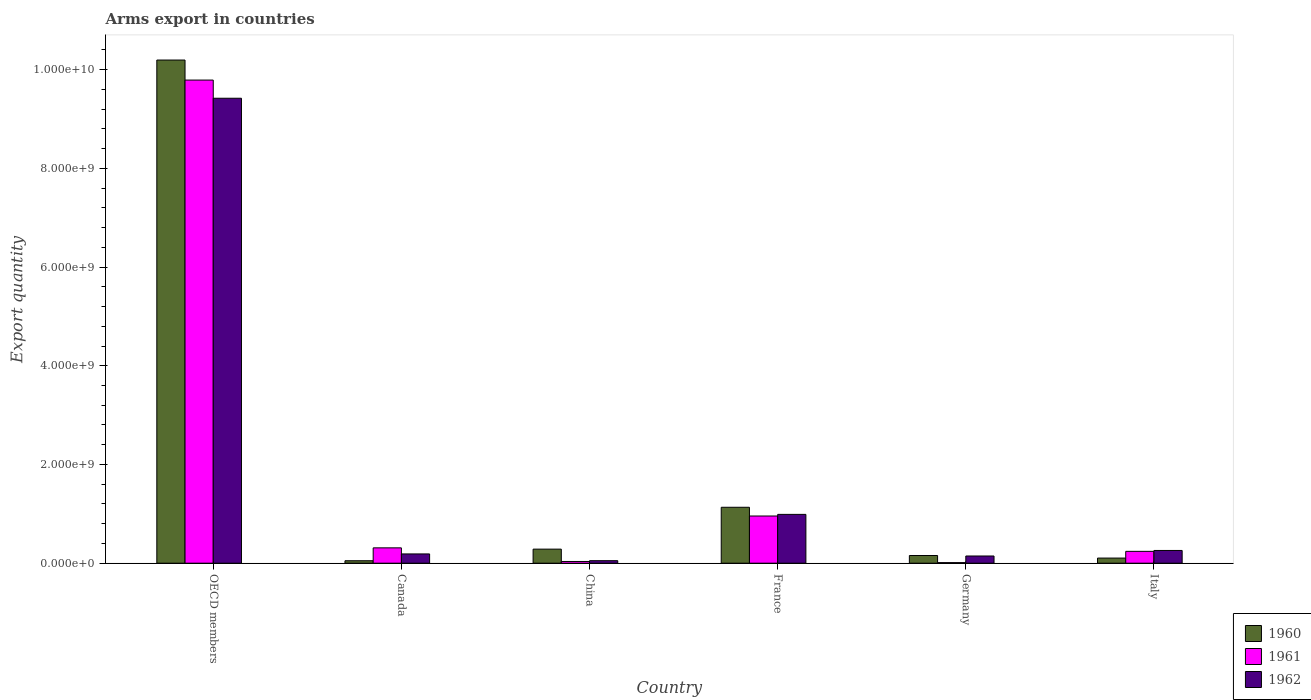How many groups of bars are there?
Your response must be concise. 6. Are the number of bars per tick equal to the number of legend labels?
Make the answer very short. Yes. How many bars are there on the 6th tick from the left?
Ensure brevity in your answer.  3. In how many cases, is the number of bars for a given country not equal to the number of legend labels?
Your answer should be compact. 0. What is the total arms export in 1961 in France?
Give a very brief answer. 9.56e+08. Across all countries, what is the maximum total arms export in 1960?
Your response must be concise. 1.02e+1. Across all countries, what is the minimum total arms export in 1962?
Provide a succinct answer. 5.10e+07. In which country was the total arms export in 1962 maximum?
Provide a succinct answer. OECD members. In which country was the total arms export in 1960 minimum?
Your response must be concise. Canada. What is the total total arms export in 1960 in the graph?
Your answer should be compact. 1.19e+1. What is the difference between the total arms export in 1961 in China and that in OECD members?
Offer a very short reply. -9.75e+09. What is the difference between the total arms export in 1960 in Canada and the total arms export in 1962 in Germany?
Ensure brevity in your answer.  -9.60e+07. What is the average total arms export in 1961 per country?
Keep it short and to the point. 1.89e+09. What is the difference between the total arms export of/in 1962 and total arms export of/in 1961 in OECD members?
Keep it short and to the point. -3.68e+08. In how many countries, is the total arms export in 1961 greater than 2000000000?
Ensure brevity in your answer.  1. What is the ratio of the total arms export in 1960 in Canada to that in China?
Your answer should be very brief. 0.18. Is the total arms export in 1962 in Canada less than that in China?
Keep it short and to the point. No. Is the difference between the total arms export in 1962 in Canada and China greater than the difference between the total arms export in 1961 in Canada and China?
Keep it short and to the point. No. What is the difference between the highest and the second highest total arms export in 1960?
Ensure brevity in your answer.  9.91e+09. What is the difference between the highest and the lowest total arms export in 1962?
Ensure brevity in your answer.  9.37e+09. Is the sum of the total arms export in 1961 in Canada and Italy greater than the maximum total arms export in 1962 across all countries?
Offer a very short reply. No. What does the 3rd bar from the left in Germany represents?
Give a very brief answer. 1962. Is it the case that in every country, the sum of the total arms export in 1960 and total arms export in 1962 is greater than the total arms export in 1961?
Offer a terse response. No. How many countries are there in the graph?
Make the answer very short. 6. Does the graph contain any zero values?
Give a very brief answer. No. Does the graph contain grids?
Your answer should be very brief. No. How many legend labels are there?
Keep it short and to the point. 3. What is the title of the graph?
Offer a very short reply. Arms export in countries. Does "1976" appear as one of the legend labels in the graph?
Your answer should be compact. No. What is the label or title of the X-axis?
Make the answer very short. Country. What is the label or title of the Y-axis?
Ensure brevity in your answer.  Export quantity. What is the Export quantity of 1960 in OECD members?
Your response must be concise. 1.02e+1. What is the Export quantity of 1961 in OECD members?
Your answer should be compact. 9.79e+09. What is the Export quantity in 1962 in OECD members?
Offer a very short reply. 9.42e+09. What is the Export quantity in 1961 in Canada?
Your answer should be very brief. 3.11e+08. What is the Export quantity of 1962 in Canada?
Provide a succinct answer. 1.88e+08. What is the Export quantity in 1960 in China?
Your answer should be very brief. 2.85e+08. What is the Export quantity of 1961 in China?
Offer a very short reply. 3.50e+07. What is the Export quantity in 1962 in China?
Your answer should be very brief. 5.10e+07. What is the Export quantity in 1960 in France?
Provide a succinct answer. 1.13e+09. What is the Export quantity in 1961 in France?
Ensure brevity in your answer.  9.56e+08. What is the Export quantity of 1962 in France?
Provide a succinct answer. 9.89e+08. What is the Export quantity of 1960 in Germany?
Keep it short and to the point. 1.56e+08. What is the Export quantity of 1962 in Germany?
Offer a terse response. 1.46e+08. What is the Export quantity of 1960 in Italy?
Offer a terse response. 1.04e+08. What is the Export quantity of 1961 in Italy?
Offer a terse response. 2.40e+08. What is the Export quantity of 1962 in Italy?
Your response must be concise. 2.58e+08. Across all countries, what is the maximum Export quantity in 1960?
Ensure brevity in your answer.  1.02e+1. Across all countries, what is the maximum Export quantity in 1961?
Your answer should be compact. 9.79e+09. Across all countries, what is the maximum Export quantity of 1962?
Make the answer very short. 9.42e+09. Across all countries, what is the minimum Export quantity of 1960?
Offer a terse response. 5.00e+07. Across all countries, what is the minimum Export quantity of 1962?
Offer a very short reply. 5.10e+07. What is the total Export quantity in 1960 in the graph?
Give a very brief answer. 1.19e+1. What is the total Export quantity in 1961 in the graph?
Offer a very short reply. 1.13e+1. What is the total Export quantity of 1962 in the graph?
Your response must be concise. 1.11e+1. What is the difference between the Export quantity of 1960 in OECD members and that in Canada?
Give a very brief answer. 1.01e+1. What is the difference between the Export quantity in 1961 in OECD members and that in Canada?
Make the answer very short. 9.48e+09. What is the difference between the Export quantity in 1962 in OECD members and that in Canada?
Offer a terse response. 9.23e+09. What is the difference between the Export quantity of 1960 in OECD members and that in China?
Provide a short and direct response. 9.91e+09. What is the difference between the Export quantity in 1961 in OECD members and that in China?
Provide a short and direct response. 9.75e+09. What is the difference between the Export quantity in 1962 in OECD members and that in China?
Offer a terse response. 9.37e+09. What is the difference between the Export quantity in 1960 in OECD members and that in France?
Offer a very short reply. 9.06e+09. What is the difference between the Export quantity of 1961 in OECD members and that in France?
Offer a very short reply. 8.83e+09. What is the difference between the Export quantity of 1962 in OECD members and that in France?
Make the answer very short. 8.43e+09. What is the difference between the Export quantity of 1960 in OECD members and that in Germany?
Provide a short and direct response. 1.00e+1. What is the difference between the Export quantity in 1961 in OECD members and that in Germany?
Make the answer very short. 9.78e+09. What is the difference between the Export quantity in 1962 in OECD members and that in Germany?
Offer a terse response. 9.27e+09. What is the difference between the Export quantity of 1960 in OECD members and that in Italy?
Make the answer very short. 1.01e+1. What is the difference between the Export quantity of 1961 in OECD members and that in Italy?
Your response must be concise. 9.55e+09. What is the difference between the Export quantity of 1962 in OECD members and that in Italy?
Give a very brief answer. 9.16e+09. What is the difference between the Export quantity of 1960 in Canada and that in China?
Your response must be concise. -2.35e+08. What is the difference between the Export quantity in 1961 in Canada and that in China?
Keep it short and to the point. 2.76e+08. What is the difference between the Export quantity of 1962 in Canada and that in China?
Keep it short and to the point. 1.37e+08. What is the difference between the Export quantity in 1960 in Canada and that in France?
Make the answer very short. -1.08e+09. What is the difference between the Export quantity in 1961 in Canada and that in France?
Your answer should be compact. -6.45e+08. What is the difference between the Export quantity in 1962 in Canada and that in France?
Keep it short and to the point. -8.01e+08. What is the difference between the Export quantity of 1960 in Canada and that in Germany?
Your response must be concise. -1.06e+08. What is the difference between the Export quantity in 1961 in Canada and that in Germany?
Your answer should be very brief. 2.99e+08. What is the difference between the Export quantity of 1962 in Canada and that in Germany?
Your answer should be very brief. 4.20e+07. What is the difference between the Export quantity in 1960 in Canada and that in Italy?
Your answer should be compact. -5.40e+07. What is the difference between the Export quantity of 1961 in Canada and that in Italy?
Provide a succinct answer. 7.10e+07. What is the difference between the Export quantity in 1962 in Canada and that in Italy?
Your answer should be very brief. -7.00e+07. What is the difference between the Export quantity in 1960 in China and that in France?
Make the answer very short. -8.48e+08. What is the difference between the Export quantity in 1961 in China and that in France?
Provide a succinct answer. -9.21e+08. What is the difference between the Export quantity of 1962 in China and that in France?
Offer a terse response. -9.38e+08. What is the difference between the Export quantity of 1960 in China and that in Germany?
Make the answer very short. 1.29e+08. What is the difference between the Export quantity in 1961 in China and that in Germany?
Your response must be concise. 2.30e+07. What is the difference between the Export quantity in 1962 in China and that in Germany?
Your response must be concise. -9.50e+07. What is the difference between the Export quantity of 1960 in China and that in Italy?
Provide a succinct answer. 1.81e+08. What is the difference between the Export quantity of 1961 in China and that in Italy?
Offer a very short reply. -2.05e+08. What is the difference between the Export quantity in 1962 in China and that in Italy?
Keep it short and to the point. -2.07e+08. What is the difference between the Export quantity of 1960 in France and that in Germany?
Offer a terse response. 9.77e+08. What is the difference between the Export quantity in 1961 in France and that in Germany?
Offer a very short reply. 9.44e+08. What is the difference between the Export quantity of 1962 in France and that in Germany?
Provide a short and direct response. 8.43e+08. What is the difference between the Export quantity in 1960 in France and that in Italy?
Provide a succinct answer. 1.03e+09. What is the difference between the Export quantity in 1961 in France and that in Italy?
Provide a succinct answer. 7.16e+08. What is the difference between the Export quantity in 1962 in France and that in Italy?
Keep it short and to the point. 7.31e+08. What is the difference between the Export quantity of 1960 in Germany and that in Italy?
Give a very brief answer. 5.20e+07. What is the difference between the Export quantity in 1961 in Germany and that in Italy?
Provide a succinct answer. -2.28e+08. What is the difference between the Export quantity in 1962 in Germany and that in Italy?
Give a very brief answer. -1.12e+08. What is the difference between the Export quantity in 1960 in OECD members and the Export quantity in 1961 in Canada?
Provide a succinct answer. 9.88e+09. What is the difference between the Export quantity in 1960 in OECD members and the Export quantity in 1962 in Canada?
Provide a short and direct response. 1.00e+1. What is the difference between the Export quantity of 1961 in OECD members and the Export quantity of 1962 in Canada?
Your answer should be very brief. 9.60e+09. What is the difference between the Export quantity in 1960 in OECD members and the Export quantity in 1961 in China?
Provide a succinct answer. 1.02e+1. What is the difference between the Export quantity of 1960 in OECD members and the Export quantity of 1962 in China?
Offer a terse response. 1.01e+1. What is the difference between the Export quantity in 1961 in OECD members and the Export quantity in 1962 in China?
Make the answer very short. 9.74e+09. What is the difference between the Export quantity of 1960 in OECD members and the Export quantity of 1961 in France?
Make the answer very short. 9.24e+09. What is the difference between the Export quantity in 1960 in OECD members and the Export quantity in 1962 in France?
Your answer should be very brief. 9.20e+09. What is the difference between the Export quantity in 1961 in OECD members and the Export quantity in 1962 in France?
Your response must be concise. 8.80e+09. What is the difference between the Export quantity of 1960 in OECD members and the Export quantity of 1961 in Germany?
Your answer should be very brief. 1.02e+1. What is the difference between the Export quantity of 1960 in OECD members and the Export quantity of 1962 in Germany?
Your answer should be compact. 1.00e+1. What is the difference between the Export quantity of 1961 in OECD members and the Export quantity of 1962 in Germany?
Your answer should be compact. 9.64e+09. What is the difference between the Export quantity of 1960 in OECD members and the Export quantity of 1961 in Italy?
Provide a short and direct response. 9.95e+09. What is the difference between the Export quantity of 1960 in OECD members and the Export quantity of 1962 in Italy?
Offer a terse response. 9.94e+09. What is the difference between the Export quantity of 1961 in OECD members and the Export quantity of 1962 in Italy?
Provide a short and direct response. 9.53e+09. What is the difference between the Export quantity in 1960 in Canada and the Export quantity in 1961 in China?
Ensure brevity in your answer.  1.50e+07. What is the difference between the Export quantity in 1960 in Canada and the Export quantity in 1962 in China?
Your response must be concise. -1.00e+06. What is the difference between the Export quantity in 1961 in Canada and the Export quantity in 1962 in China?
Keep it short and to the point. 2.60e+08. What is the difference between the Export quantity of 1960 in Canada and the Export quantity of 1961 in France?
Your response must be concise. -9.06e+08. What is the difference between the Export quantity in 1960 in Canada and the Export quantity in 1962 in France?
Offer a very short reply. -9.39e+08. What is the difference between the Export quantity of 1961 in Canada and the Export quantity of 1962 in France?
Provide a short and direct response. -6.78e+08. What is the difference between the Export quantity in 1960 in Canada and the Export quantity in 1961 in Germany?
Give a very brief answer. 3.80e+07. What is the difference between the Export quantity of 1960 in Canada and the Export quantity of 1962 in Germany?
Keep it short and to the point. -9.60e+07. What is the difference between the Export quantity of 1961 in Canada and the Export quantity of 1962 in Germany?
Offer a terse response. 1.65e+08. What is the difference between the Export quantity in 1960 in Canada and the Export quantity in 1961 in Italy?
Give a very brief answer. -1.90e+08. What is the difference between the Export quantity of 1960 in Canada and the Export quantity of 1962 in Italy?
Provide a short and direct response. -2.08e+08. What is the difference between the Export quantity of 1961 in Canada and the Export quantity of 1962 in Italy?
Ensure brevity in your answer.  5.30e+07. What is the difference between the Export quantity of 1960 in China and the Export quantity of 1961 in France?
Offer a very short reply. -6.71e+08. What is the difference between the Export quantity in 1960 in China and the Export quantity in 1962 in France?
Your answer should be compact. -7.04e+08. What is the difference between the Export quantity of 1961 in China and the Export quantity of 1962 in France?
Offer a very short reply. -9.54e+08. What is the difference between the Export quantity of 1960 in China and the Export quantity of 1961 in Germany?
Provide a short and direct response. 2.73e+08. What is the difference between the Export quantity of 1960 in China and the Export quantity of 1962 in Germany?
Your response must be concise. 1.39e+08. What is the difference between the Export quantity in 1961 in China and the Export quantity in 1962 in Germany?
Your answer should be compact. -1.11e+08. What is the difference between the Export quantity in 1960 in China and the Export quantity in 1961 in Italy?
Make the answer very short. 4.50e+07. What is the difference between the Export quantity in 1960 in China and the Export quantity in 1962 in Italy?
Make the answer very short. 2.70e+07. What is the difference between the Export quantity in 1961 in China and the Export quantity in 1962 in Italy?
Offer a terse response. -2.23e+08. What is the difference between the Export quantity in 1960 in France and the Export quantity in 1961 in Germany?
Make the answer very short. 1.12e+09. What is the difference between the Export quantity in 1960 in France and the Export quantity in 1962 in Germany?
Give a very brief answer. 9.87e+08. What is the difference between the Export quantity of 1961 in France and the Export quantity of 1962 in Germany?
Keep it short and to the point. 8.10e+08. What is the difference between the Export quantity in 1960 in France and the Export quantity in 1961 in Italy?
Your response must be concise. 8.93e+08. What is the difference between the Export quantity of 1960 in France and the Export quantity of 1962 in Italy?
Provide a succinct answer. 8.75e+08. What is the difference between the Export quantity of 1961 in France and the Export quantity of 1962 in Italy?
Keep it short and to the point. 6.98e+08. What is the difference between the Export quantity of 1960 in Germany and the Export quantity of 1961 in Italy?
Give a very brief answer. -8.40e+07. What is the difference between the Export quantity in 1960 in Germany and the Export quantity in 1962 in Italy?
Your response must be concise. -1.02e+08. What is the difference between the Export quantity in 1961 in Germany and the Export quantity in 1962 in Italy?
Your answer should be compact. -2.46e+08. What is the average Export quantity of 1960 per country?
Your response must be concise. 1.99e+09. What is the average Export quantity in 1961 per country?
Offer a very short reply. 1.89e+09. What is the average Export quantity of 1962 per country?
Provide a short and direct response. 1.84e+09. What is the difference between the Export quantity of 1960 and Export quantity of 1961 in OECD members?
Provide a succinct answer. 4.06e+08. What is the difference between the Export quantity of 1960 and Export quantity of 1962 in OECD members?
Give a very brief answer. 7.74e+08. What is the difference between the Export quantity of 1961 and Export quantity of 1962 in OECD members?
Give a very brief answer. 3.68e+08. What is the difference between the Export quantity in 1960 and Export quantity in 1961 in Canada?
Your answer should be compact. -2.61e+08. What is the difference between the Export quantity of 1960 and Export quantity of 1962 in Canada?
Ensure brevity in your answer.  -1.38e+08. What is the difference between the Export quantity in 1961 and Export quantity in 1962 in Canada?
Keep it short and to the point. 1.23e+08. What is the difference between the Export quantity of 1960 and Export quantity of 1961 in China?
Give a very brief answer. 2.50e+08. What is the difference between the Export quantity in 1960 and Export quantity in 1962 in China?
Provide a short and direct response. 2.34e+08. What is the difference between the Export quantity of 1961 and Export quantity of 1962 in China?
Make the answer very short. -1.60e+07. What is the difference between the Export quantity of 1960 and Export quantity of 1961 in France?
Provide a succinct answer. 1.77e+08. What is the difference between the Export quantity in 1960 and Export quantity in 1962 in France?
Ensure brevity in your answer.  1.44e+08. What is the difference between the Export quantity of 1961 and Export quantity of 1962 in France?
Your answer should be compact. -3.30e+07. What is the difference between the Export quantity of 1960 and Export quantity of 1961 in Germany?
Provide a short and direct response. 1.44e+08. What is the difference between the Export quantity in 1960 and Export quantity in 1962 in Germany?
Your answer should be compact. 1.00e+07. What is the difference between the Export quantity of 1961 and Export quantity of 1962 in Germany?
Your answer should be very brief. -1.34e+08. What is the difference between the Export quantity of 1960 and Export quantity of 1961 in Italy?
Make the answer very short. -1.36e+08. What is the difference between the Export quantity of 1960 and Export quantity of 1962 in Italy?
Your response must be concise. -1.54e+08. What is the difference between the Export quantity in 1961 and Export quantity in 1962 in Italy?
Your answer should be very brief. -1.80e+07. What is the ratio of the Export quantity in 1960 in OECD members to that in Canada?
Offer a terse response. 203.88. What is the ratio of the Export quantity in 1961 in OECD members to that in Canada?
Provide a short and direct response. 31.47. What is the ratio of the Export quantity of 1962 in OECD members to that in Canada?
Your answer should be very brief. 50.11. What is the ratio of the Export quantity in 1960 in OECD members to that in China?
Provide a succinct answer. 35.77. What is the ratio of the Export quantity of 1961 in OECD members to that in China?
Make the answer very short. 279.66. What is the ratio of the Export quantity in 1962 in OECD members to that in China?
Give a very brief answer. 184.71. What is the ratio of the Export quantity of 1960 in OECD members to that in France?
Ensure brevity in your answer.  9. What is the ratio of the Export quantity of 1961 in OECD members to that in France?
Provide a succinct answer. 10.24. What is the ratio of the Export quantity of 1962 in OECD members to that in France?
Your response must be concise. 9.52. What is the ratio of the Export quantity of 1960 in OECD members to that in Germany?
Give a very brief answer. 65.35. What is the ratio of the Export quantity of 1961 in OECD members to that in Germany?
Offer a very short reply. 815.67. What is the ratio of the Export quantity of 1962 in OECD members to that in Germany?
Give a very brief answer. 64.52. What is the ratio of the Export quantity of 1960 in OECD members to that in Italy?
Provide a succinct answer. 98.02. What is the ratio of the Export quantity of 1961 in OECD members to that in Italy?
Ensure brevity in your answer.  40.78. What is the ratio of the Export quantity of 1962 in OECD members to that in Italy?
Offer a terse response. 36.51. What is the ratio of the Export quantity of 1960 in Canada to that in China?
Give a very brief answer. 0.18. What is the ratio of the Export quantity of 1961 in Canada to that in China?
Make the answer very short. 8.89. What is the ratio of the Export quantity of 1962 in Canada to that in China?
Provide a succinct answer. 3.69. What is the ratio of the Export quantity of 1960 in Canada to that in France?
Your response must be concise. 0.04. What is the ratio of the Export quantity of 1961 in Canada to that in France?
Provide a succinct answer. 0.33. What is the ratio of the Export quantity in 1962 in Canada to that in France?
Give a very brief answer. 0.19. What is the ratio of the Export quantity of 1960 in Canada to that in Germany?
Offer a very short reply. 0.32. What is the ratio of the Export quantity of 1961 in Canada to that in Germany?
Offer a terse response. 25.92. What is the ratio of the Export quantity of 1962 in Canada to that in Germany?
Give a very brief answer. 1.29. What is the ratio of the Export quantity of 1960 in Canada to that in Italy?
Keep it short and to the point. 0.48. What is the ratio of the Export quantity of 1961 in Canada to that in Italy?
Your response must be concise. 1.3. What is the ratio of the Export quantity of 1962 in Canada to that in Italy?
Offer a very short reply. 0.73. What is the ratio of the Export quantity in 1960 in China to that in France?
Offer a terse response. 0.25. What is the ratio of the Export quantity in 1961 in China to that in France?
Your answer should be compact. 0.04. What is the ratio of the Export quantity of 1962 in China to that in France?
Offer a terse response. 0.05. What is the ratio of the Export quantity of 1960 in China to that in Germany?
Provide a succinct answer. 1.83. What is the ratio of the Export quantity in 1961 in China to that in Germany?
Make the answer very short. 2.92. What is the ratio of the Export quantity in 1962 in China to that in Germany?
Offer a very short reply. 0.35. What is the ratio of the Export quantity of 1960 in China to that in Italy?
Provide a short and direct response. 2.74. What is the ratio of the Export quantity in 1961 in China to that in Italy?
Offer a very short reply. 0.15. What is the ratio of the Export quantity of 1962 in China to that in Italy?
Offer a terse response. 0.2. What is the ratio of the Export quantity of 1960 in France to that in Germany?
Your response must be concise. 7.26. What is the ratio of the Export quantity in 1961 in France to that in Germany?
Give a very brief answer. 79.67. What is the ratio of the Export quantity of 1962 in France to that in Germany?
Give a very brief answer. 6.77. What is the ratio of the Export quantity in 1960 in France to that in Italy?
Keep it short and to the point. 10.89. What is the ratio of the Export quantity in 1961 in France to that in Italy?
Your response must be concise. 3.98. What is the ratio of the Export quantity of 1962 in France to that in Italy?
Keep it short and to the point. 3.83. What is the ratio of the Export quantity in 1961 in Germany to that in Italy?
Your answer should be very brief. 0.05. What is the ratio of the Export quantity of 1962 in Germany to that in Italy?
Provide a succinct answer. 0.57. What is the difference between the highest and the second highest Export quantity of 1960?
Your answer should be very brief. 9.06e+09. What is the difference between the highest and the second highest Export quantity of 1961?
Give a very brief answer. 8.83e+09. What is the difference between the highest and the second highest Export quantity in 1962?
Provide a short and direct response. 8.43e+09. What is the difference between the highest and the lowest Export quantity of 1960?
Keep it short and to the point. 1.01e+1. What is the difference between the highest and the lowest Export quantity of 1961?
Your response must be concise. 9.78e+09. What is the difference between the highest and the lowest Export quantity in 1962?
Provide a succinct answer. 9.37e+09. 